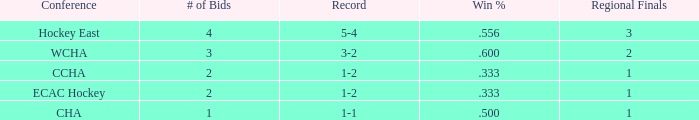In the hockey east conference, what is the cumulative number of win percentages when fewer than 4 bids are present? 0.0. 